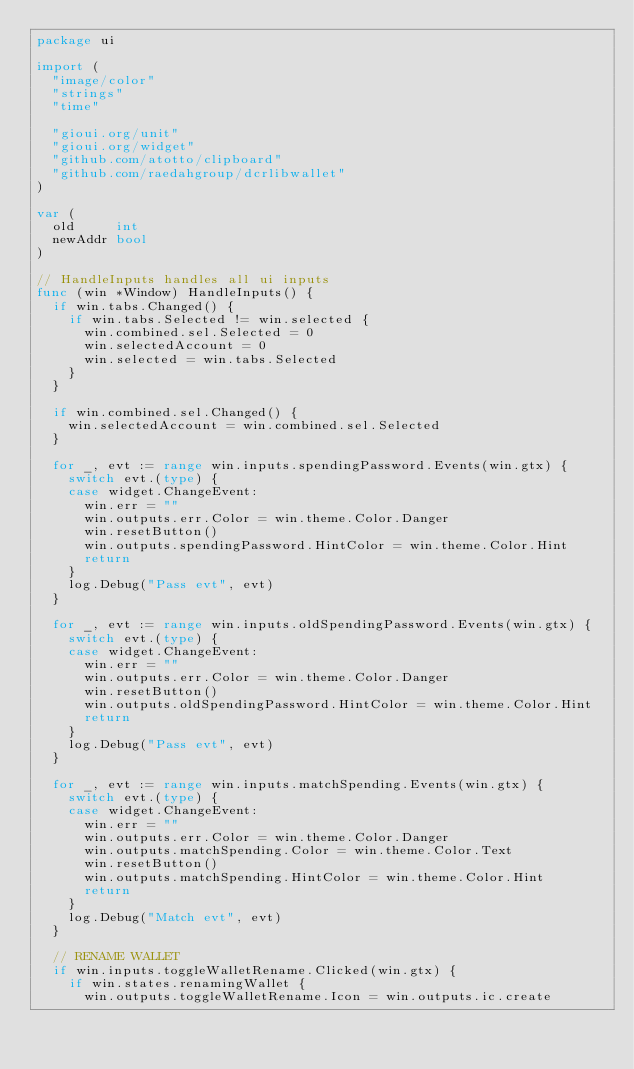<code> <loc_0><loc_0><loc_500><loc_500><_Go_>package ui

import (
	"image/color"
	"strings"
	"time"

	"gioui.org/unit"
	"gioui.org/widget"
	"github.com/atotto/clipboard"
	"github.com/raedahgroup/dcrlibwallet"
)

var (
	old     int
	newAddr bool
)

// HandleInputs handles all ui inputs
func (win *Window) HandleInputs() {
	if win.tabs.Changed() {
		if win.tabs.Selected != win.selected {
			win.combined.sel.Selected = 0
			win.selectedAccount = 0
			win.selected = win.tabs.Selected
		}
	}

	if win.combined.sel.Changed() {
		win.selectedAccount = win.combined.sel.Selected
	}

	for _, evt := range win.inputs.spendingPassword.Events(win.gtx) {
		switch evt.(type) {
		case widget.ChangeEvent:
			win.err = ""
			win.outputs.err.Color = win.theme.Color.Danger
			win.resetButton()
			win.outputs.spendingPassword.HintColor = win.theme.Color.Hint
			return
		}
		log.Debug("Pass evt", evt)
	}

	for _, evt := range win.inputs.oldSpendingPassword.Events(win.gtx) {
		switch evt.(type) {
		case widget.ChangeEvent:
			win.err = ""
			win.outputs.err.Color = win.theme.Color.Danger
			win.resetButton()
			win.outputs.oldSpendingPassword.HintColor = win.theme.Color.Hint
			return
		}
		log.Debug("Pass evt", evt)
	}

	for _, evt := range win.inputs.matchSpending.Events(win.gtx) {
		switch evt.(type) {
		case widget.ChangeEvent:
			win.err = ""
			win.outputs.err.Color = win.theme.Color.Danger
			win.outputs.matchSpending.Color = win.theme.Color.Text
			win.resetButton()
			win.outputs.matchSpending.HintColor = win.theme.Color.Hint
			return
		}
		log.Debug("Match evt", evt)
	}

	// RENAME WALLET
	if win.inputs.toggleWalletRename.Clicked(win.gtx) {
		if win.states.renamingWallet {
			win.outputs.toggleWalletRename.Icon = win.outputs.ic.create</code> 